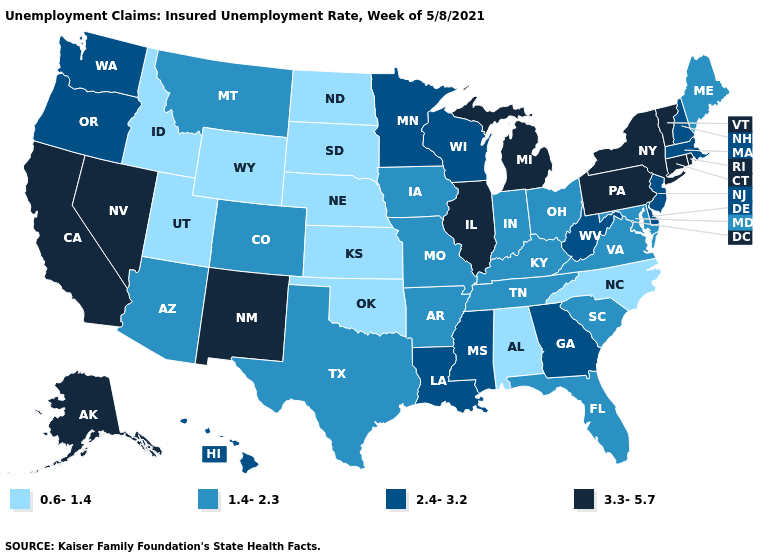What is the lowest value in the West?
Keep it brief. 0.6-1.4. Is the legend a continuous bar?
Answer briefly. No. Does Delaware have the highest value in the South?
Concise answer only. Yes. Name the states that have a value in the range 2.4-3.2?
Answer briefly. Delaware, Georgia, Hawaii, Louisiana, Massachusetts, Minnesota, Mississippi, New Hampshire, New Jersey, Oregon, Washington, West Virginia, Wisconsin. Name the states that have a value in the range 3.3-5.7?
Give a very brief answer. Alaska, California, Connecticut, Illinois, Michigan, Nevada, New Mexico, New York, Pennsylvania, Rhode Island, Vermont. Name the states that have a value in the range 1.4-2.3?
Answer briefly. Arizona, Arkansas, Colorado, Florida, Indiana, Iowa, Kentucky, Maine, Maryland, Missouri, Montana, Ohio, South Carolina, Tennessee, Texas, Virginia. How many symbols are there in the legend?
Keep it brief. 4. What is the value of Washington?
Short answer required. 2.4-3.2. Name the states that have a value in the range 2.4-3.2?
Be succinct. Delaware, Georgia, Hawaii, Louisiana, Massachusetts, Minnesota, Mississippi, New Hampshire, New Jersey, Oregon, Washington, West Virginia, Wisconsin. Name the states that have a value in the range 3.3-5.7?
Answer briefly. Alaska, California, Connecticut, Illinois, Michigan, Nevada, New Mexico, New York, Pennsylvania, Rhode Island, Vermont. Is the legend a continuous bar?
Be succinct. No. What is the lowest value in states that border New Mexico?
Quick response, please. 0.6-1.4. Among the states that border Nevada , which have the highest value?
Concise answer only. California. Name the states that have a value in the range 3.3-5.7?
Short answer required. Alaska, California, Connecticut, Illinois, Michigan, Nevada, New Mexico, New York, Pennsylvania, Rhode Island, Vermont. Does Washington have a higher value than Montana?
Concise answer only. Yes. 